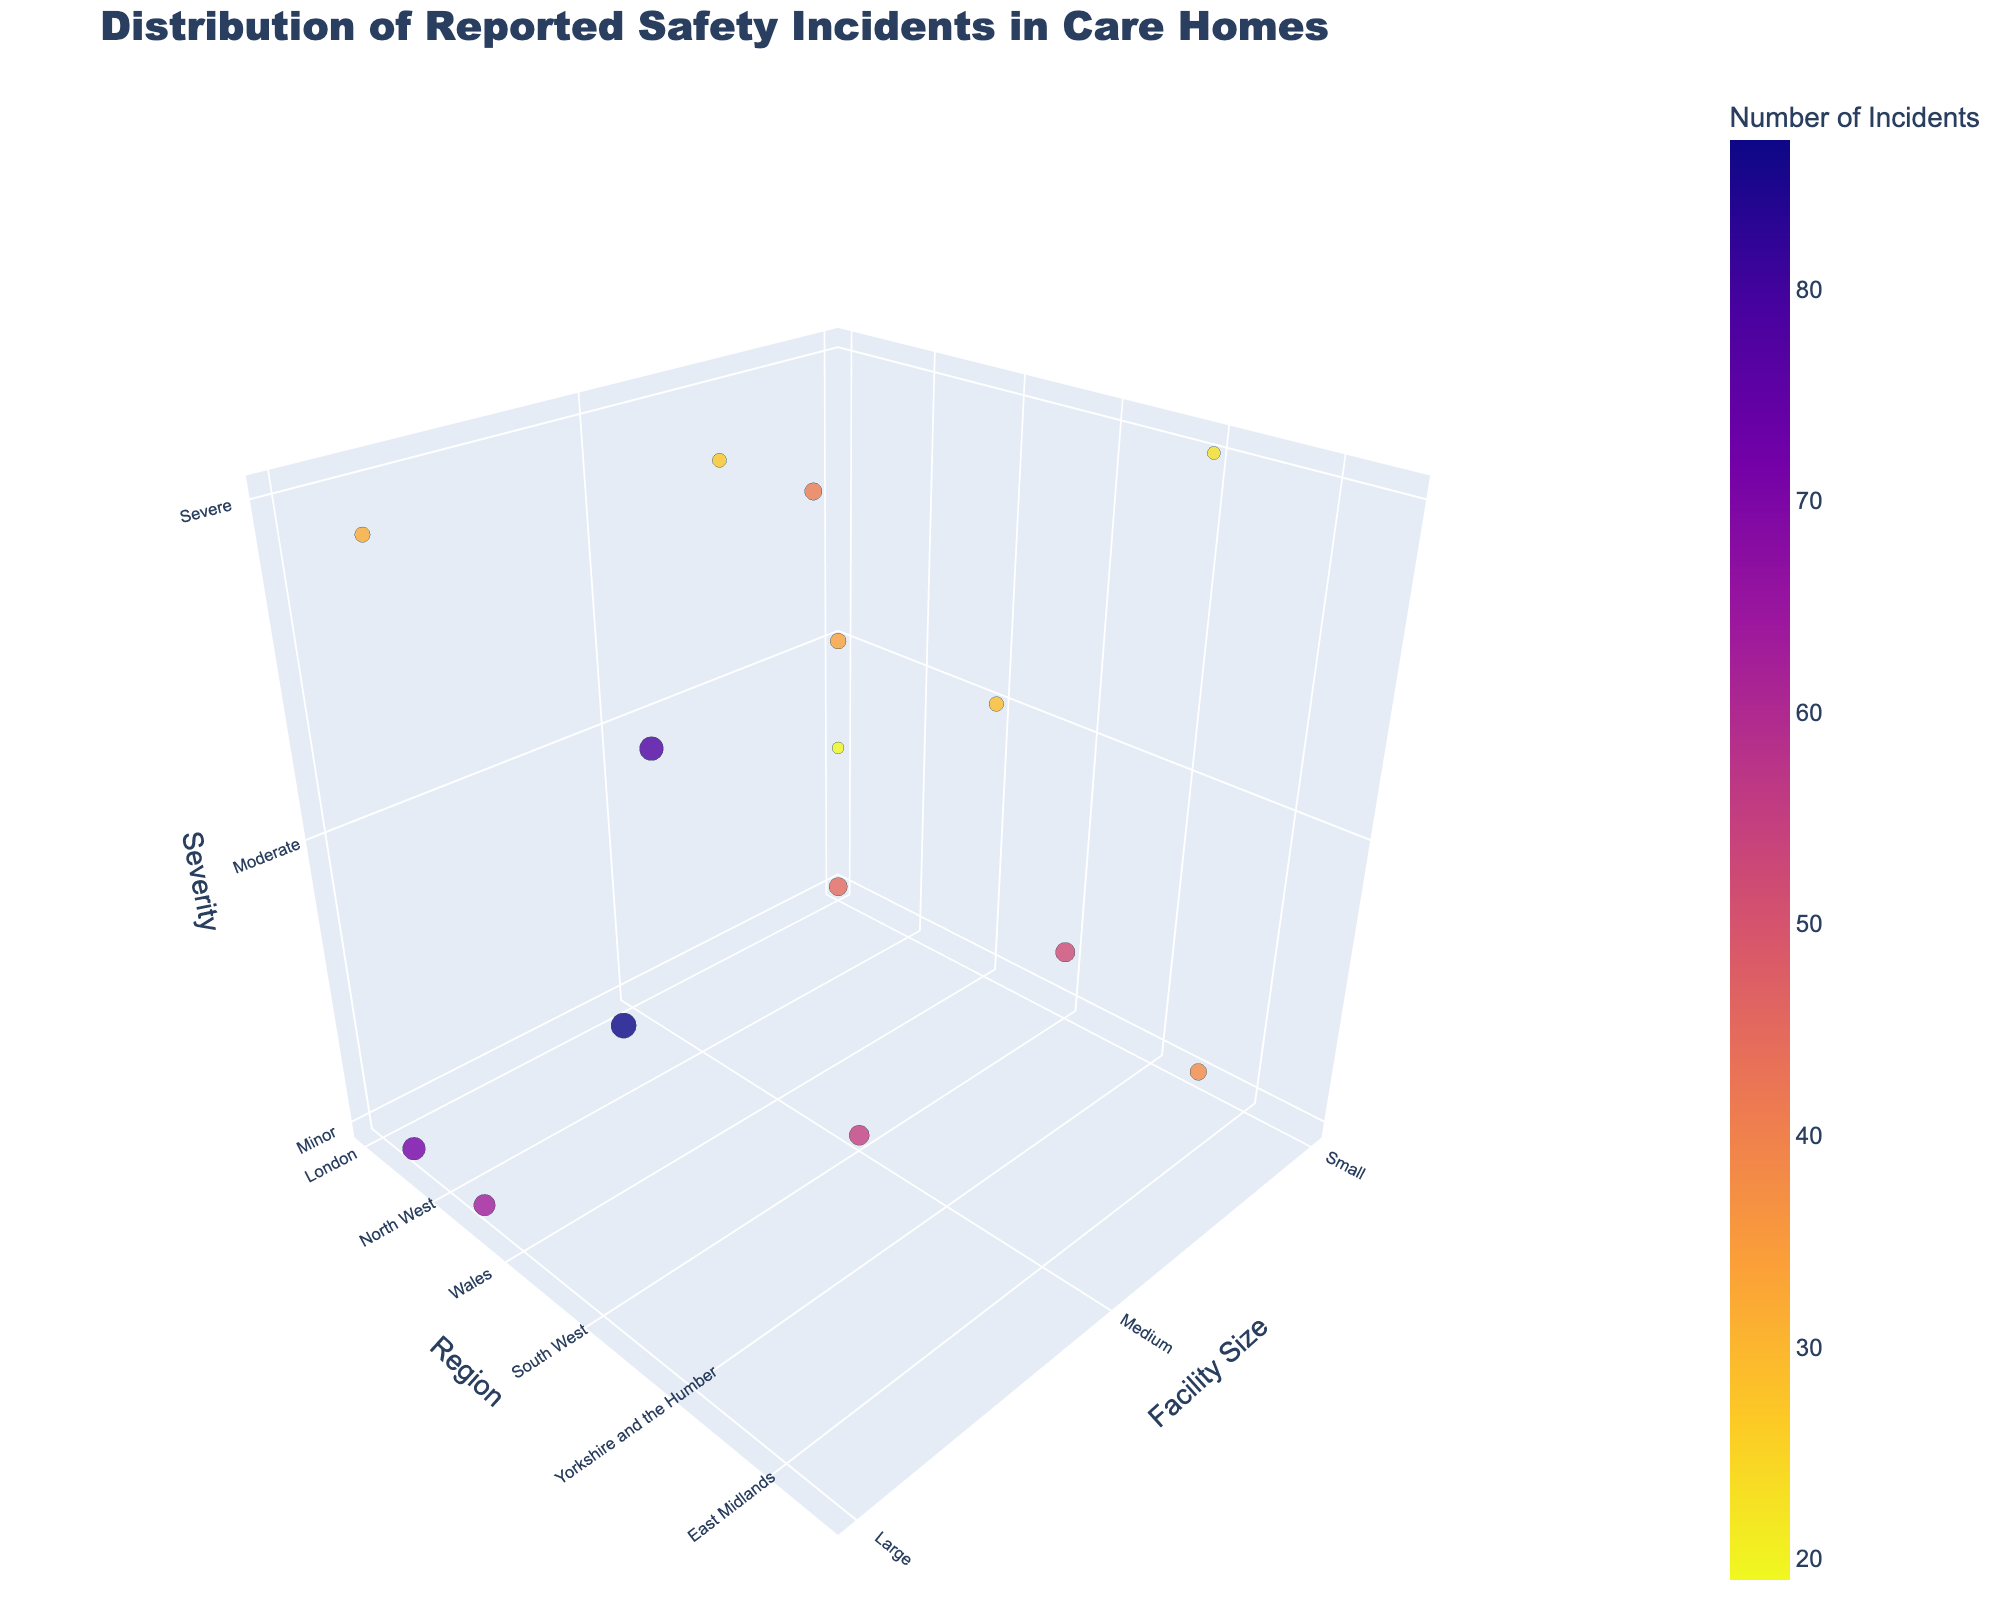What's the title of the chart? The title is typically displayed at the top of the chart in larger, bold font, making it easy to identify.
Answer: Distribution of Reported Safety Incidents in Care Homes What does the size of the bubbles represent? The legend and axis labels often indicate what each visual element represents. In this chart, the size of the bubbles is explained in the legend as corresponding to the number of incidents.
Answer: Number of Incidents Which region has the highest number of severe incidents? To find this, look for the largest bubble within the 'Severe' category on the z-axis and check its corresponding y-axis label.
Answer: East of England How many incidents were reported in small facilities in London? Locate the bubble corresponding to small facility size on the x-axis and position it at 'London' on the y-axis, then read the size value in the hover or legend.
Answer: 45 What region has the largest bubble in the 'Minor' severity category? Identify the largest bubble within the 'Minor' category on the z-axis and confirm its geographic location on the y-axis.
Answer: South East Which severity level has more incidents reported in medium-sized facilities, minor or severe? Compare the bubble sizes for the 'Minor' and 'Severe' severity levels within the medium facility size on the x-axis.
Answer: Minor How does the number of incidents in large facilities in the North West compare with those in Northern Ireland? Compare the bubble sizes for large facilities in both 'North West' and 'Northern Ireland' regions by examining their positions on the y-axis and the number of incidents (size).
Answer: North West has more incidents What can you infer about the distribution of severe incidents across different facility sizes? By examining the z-axis for 'Severe' incidents and comparing bubble sizes and distribution along the x-axis (facility size), one can infer the relative risk levels in different facility sizes.
Answer: Varies widely; no single size dominates Is there any region where moderate incidents are extremely low regardless of facility size? Look for smaller bubbles within the ‘Moderate’ category on the z-axis spread across different facility sizes and check the corresponding regions on the y-axis.
Answer: Wales 